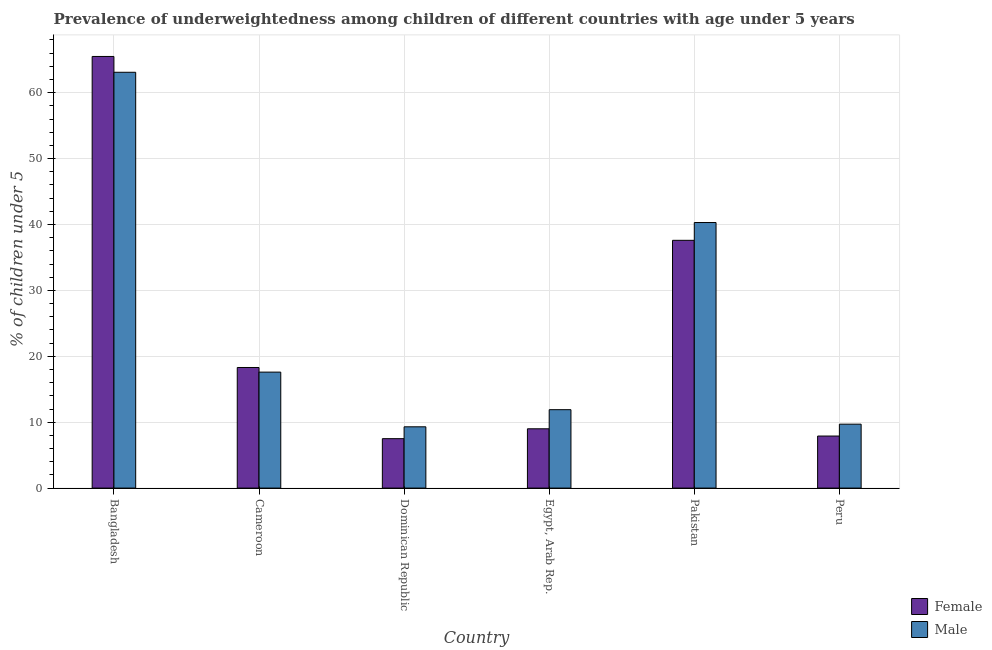How many different coloured bars are there?
Keep it short and to the point. 2. Are the number of bars per tick equal to the number of legend labels?
Provide a succinct answer. Yes. Are the number of bars on each tick of the X-axis equal?
Your answer should be very brief. Yes. How many bars are there on the 5th tick from the left?
Your answer should be very brief. 2. How many bars are there on the 1st tick from the right?
Your answer should be very brief. 2. What is the label of the 3rd group of bars from the left?
Your response must be concise. Dominican Republic. What is the percentage of underweighted male children in Egypt, Arab Rep.?
Ensure brevity in your answer.  11.9. Across all countries, what is the maximum percentage of underweighted female children?
Your answer should be compact. 65.5. Across all countries, what is the minimum percentage of underweighted male children?
Your answer should be very brief. 9.3. In which country was the percentage of underweighted female children maximum?
Give a very brief answer. Bangladesh. In which country was the percentage of underweighted female children minimum?
Provide a short and direct response. Dominican Republic. What is the total percentage of underweighted male children in the graph?
Your answer should be compact. 151.9. What is the difference between the percentage of underweighted female children in Bangladesh and that in Pakistan?
Your answer should be compact. 27.9. What is the difference between the percentage of underweighted female children in Bangladesh and the percentage of underweighted male children in Egypt, Arab Rep.?
Provide a short and direct response. 53.6. What is the average percentage of underweighted male children per country?
Provide a short and direct response. 25.32. What is the difference between the percentage of underweighted female children and percentage of underweighted male children in Bangladesh?
Make the answer very short. 2.4. In how many countries, is the percentage of underweighted female children greater than 66 %?
Offer a very short reply. 0. What is the ratio of the percentage of underweighted male children in Cameroon to that in Egypt, Arab Rep.?
Ensure brevity in your answer.  1.48. Is the percentage of underweighted female children in Cameroon less than that in Dominican Republic?
Ensure brevity in your answer.  No. Is the difference between the percentage of underweighted female children in Bangladesh and Pakistan greater than the difference between the percentage of underweighted male children in Bangladesh and Pakistan?
Offer a terse response. Yes. What is the difference between the highest and the second highest percentage of underweighted male children?
Provide a succinct answer. 22.8. What is the difference between the highest and the lowest percentage of underweighted male children?
Give a very brief answer. 53.8. Is the sum of the percentage of underweighted female children in Pakistan and Peru greater than the maximum percentage of underweighted male children across all countries?
Keep it short and to the point. No. What does the 1st bar from the left in Dominican Republic represents?
Provide a short and direct response. Female. How many countries are there in the graph?
Ensure brevity in your answer.  6. Are the values on the major ticks of Y-axis written in scientific E-notation?
Ensure brevity in your answer.  No. Does the graph contain grids?
Give a very brief answer. Yes. How are the legend labels stacked?
Your response must be concise. Vertical. What is the title of the graph?
Provide a short and direct response. Prevalence of underweightedness among children of different countries with age under 5 years. Does "Study and work" appear as one of the legend labels in the graph?
Offer a very short reply. No. What is the label or title of the Y-axis?
Provide a short and direct response.  % of children under 5. What is the  % of children under 5 of Female in Bangladesh?
Offer a terse response. 65.5. What is the  % of children under 5 of Male in Bangladesh?
Your answer should be compact. 63.1. What is the  % of children under 5 of Female in Cameroon?
Your answer should be very brief. 18.3. What is the  % of children under 5 in Male in Cameroon?
Provide a succinct answer. 17.6. What is the  % of children under 5 in Male in Dominican Republic?
Offer a very short reply. 9.3. What is the  % of children under 5 of Male in Egypt, Arab Rep.?
Keep it short and to the point. 11.9. What is the  % of children under 5 of Female in Pakistan?
Make the answer very short. 37.6. What is the  % of children under 5 in Male in Pakistan?
Your answer should be very brief. 40.3. What is the  % of children under 5 of Female in Peru?
Make the answer very short. 7.9. What is the  % of children under 5 of Male in Peru?
Provide a short and direct response. 9.7. Across all countries, what is the maximum  % of children under 5 of Female?
Your answer should be very brief. 65.5. Across all countries, what is the maximum  % of children under 5 of Male?
Provide a succinct answer. 63.1. Across all countries, what is the minimum  % of children under 5 of Female?
Provide a succinct answer. 7.5. Across all countries, what is the minimum  % of children under 5 of Male?
Your response must be concise. 9.3. What is the total  % of children under 5 in Female in the graph?
Provide a short and direct response. 145.8. What is the total  % of children under 5 in Male in the graph?
Give a very brief answer. 151.9. What is the difference between the  % of children under 5 in Female in Bangladesh and that in Cameroon?
Provide a short and direct response. 47.2. What is the difference between the  % of children under 5 in Male in Bangladesh and that in Cameroon?
Your answer should be compact. 45.5. What is the difference between the  % of children under 5 of Female in Bangladesh and that in Dominican Republic?
Give a very brief answer. 58. What is the difference between the  % of children under 5 of Male in Bangladesh and that in Dominican Republic?
Give a very brief answer. 53.8. What is the difference between the  % of children under 5 in Female in Bangladesh and that in Egypt, Arab Rep.?
Your answer should be very brief. 56.5. What is the difference between the  % of children under 5 of Male in Bangladesh and that in Egypt, Arab Rep.?
Provide a succinct answer. 51.2. What is the difference between the  % of children under 5 in Female in Bangladesh and that in Pakistan?
Offer a terse response. 27.9. What is the difference between the  % of children under 5 of Male in Bangladesh and that in Pakistan?
Your answer should be very brief. 22.8. What is the difference between the  % of children under 5 in Female in Bangladesh and that in Peru?
Your response must be concise. 57.6. What is the difference between the  % of children under 5 of Male in Bangladesh and that in Peru?
Your answer should be very brief. 53.4. What is the difference between the  % of children under 5 of Male in Cameroon and that in Dominican Republic?
Offer a very short reply. 8.3. What is the difference between the  % of children under 5 of Female in Cameroon and that in Pakistan?
Your answer should be very brief. -19.3. What is the difference between the  % of children under 5 of Male in Cameroon and that in Pakistan?
Your answer should be very brief. -22.7. What is the difference between the  % of children under 5 of Male in Cameroon and that in Peru?
Make the answer very short. 7.9. What is the difference between the  % of children under 5 of Female in Dominican Republic and that in Egypt, Arab Rep.?
Ensure brevity in your answer.  -1.5. What is the difference between the  % of children under 5 of Male in Dominican Republic and that in Egypt, Arab Rep.?
Ensure brevity in your answer.  -2.6. What is the difference between the  % of children under 5 in Female in Dominican Republic and that in Pakistan?
Your answer should be compact. -30.1. What is the difference between the  % of children under 5 of Male in Dominican Republic and that in Pakistan?
Make the answer very short. -31. What is the difference between the  % of children under 5 of Female in Dominican Republic and that in Peru?
Ensure brevity in your answer.  -0.4. What is the difference between the  % of children under 5 of Male in Dominican Republic and that in Peru?
Keep it short and to the point. -0.4. What is the difference between the  % of children under 5 of Female in Egypt, Arab Rep. and that in Pakistan?
Provide a succinct answer. -28.6. What is the difference between the  % of children under 5 in Male in Egypt, Arab Rep. and that in Pakistan?
Provide a short and direct response. -28.4. What is the difference between the  % of children under 5 in Female in Pakistan and that in Peru?
Keep it short and to the point. 29.7. What is the difference between the  % of children under 5 of Male in Pakistan and that in Peru?
Your response must be concise. 30.6. What is the difference between the  % of children under 5 of Female in Bangladesh and the  % of children under 5 of Male in Cameroon?
Give a very brief answer. 47.9. What is the difference between the  % of children under 5 in Female in Bangladesh and the  % of children under 5 in Male in Dominican Republic?
Make the answer very short. 56.2. What is the difference between the  % of children under 5 in Female in Bangladesh and the  % of children under 5 in Male in Egypt, Arab Rep.?
Keep it short and to the point. 53.6. What is the difference between the  % of children under 5 of Female in Bangladesh and the  % of children under 5 of Male in Pakistan?
Your answer should be very brief. 25.2. What is the difference between the  % of children under 5 in Female in Bangladesh and the  % of children under 5 in Male in Peru?
Your response must be concise. 55.8. What is the difference between the  % of children under 5 of Female in Cameroon and the  % of children under 5 of Male in Dominican Republic?
Offer a terse response. 9. What is the difference between the  % of children under 5 in Female in Cameroon and the  % of children under 5 in Male in Egypt, Arab Rep.?
Your response must be concise. 6.4. What is the difference between the  % of children under 5 in Female in Dominican Republic and the  % of children under 5 in Male in Egypt, Arab Rep.?
Offer a terse response. -4.4. What is the difference between the  % of children under 5 of Female in Dominican Republic and the  % of children under 5 of Male in Pakistan?
Ensure brevity in your answer.  -32.8. What is the difference between the  % of children under 5 in Female in Egypt, Arab Rep. and the  % of children under 5 in Male in Pakistan?
Your answer should be very brief. -31.3. What is the difference between the  % of children under 5 in Female in Pakistan and the  % of children under 5 in Male in Peru?
Ensure brevity in your answer.  27.9. What is the average  % of children under 5 in Female per country?
Offer a terse response. 24.3. What is the average  % of children under 5 in Male per country?
Your answer should be very brief. 25.32. What is the difference between the  % of children under 5 of Female and  % of children under 5 of Male in Cameroon?
Give a very brief answer. 0.7. What is the difference between the  % of children under 5 of Female and  % of children under 5 of Male in Dominican Republic?
Your answer should be very brief. -1.8. What is the difference between the  % of children under 5 of Female and  % of children under 5 of Male in Egypt, Arab Rep.?
Offer a terse response. -2.9. What is the difference between the  % of children under 5 in Female and  % of children under 5 in Male in Pakistan?
Give a very brief answer. -2.7. What is the ratio of the  % of children under 5 of Female in Bangladesh to that in Cameroon?
Your answer should be very brief. 3.58. What is the ratio of the  % of children under 5 of Male in Bangladesh to that in Cameroon?
Your answer should be compact. 3.59. What is the ratio of the  % of children under 5 in Female in Bangladesh to that in Dominican Republic?
Provide a succinct answer. 8.73. What is the ratio of the  % of children under 5 of Male in Bangladesh to that in Dominican Republic?
Ensure brevity in your answer.  6.78. What is the ratio of the  % of children under 5 in Female in Bangladesh to that in Egypt, Arab Rep.?
Provide a succinct answer. 7.28. What is the ratio of the  % of children under 5 in Male in Bangladesh to that in Egypt, Arab Rep.?
Your response must be concise. 5.3. What is the ratio of the  % of children under 5 of Female in Bangladesh to that in Pakistan?
Offer a very short reply. 1.74. What is the ratio of the  % of children under 5 in Male in Bangladesh to that in Pakistan?
Your answer should be compact. 1.57. What is the ratio of the  % of children under 5 of Female in Bangladesh to that in Peru?
Keep it short and to the point. 8.29. What is the ratio of the  % of children under 5 of Male in Bangladesh to that in Peru?
Offer a terse response. 6.51. What is the ratio of the  % of children under 5 in Female in Cameroon to that in Dominican Republic?
Offer a very short reply. 2.44. What is the ratio of the  % of children under 5 in Male in Cameroon to that in Dominican Republic?
Your answer should be very brief. 1.89. What is the ratio of the  % of children under 5 in Female in Cameroon to that in Egypt, Arab Rep.?
Your answer should be compact. 2.03. What is the ratio of the  % of children under 5 of Male in Cameroon to that in Egypt, Arab Rep.?
Your answer should be compact. 1.48. What is the ratio of the  % of children under 5 of Female in Cameroon to that in Pakistan?
Your answer should be compact. 0.49. What is the ratio of the  % of children under 5 of Male in Cameroon to that in Pakistan?
Offer a terse response. 0.44. What is the ratio of the  % of children under 5 of Female in Cameroon to that in Peru?
Your answer should be very brief. 2.32. What is the ratio of the  % of children under 5 in Male in Cameroon to that in Peru?
Make the answer very short. 1.81. What is the ratio of the  % of children under 5 of Female in Dominican Republic to that in Egypt, Arab Rep.?
Offer a terse response. 0.83. What is the ratio of the  % of children under 5 of Male in Dominican Republic to that in Egypt, Arab Rep.?
Your answer should be very brief. 0.78. What is the ratio of the  % of children under 5 in Female in Dominican Republic to that in Pakistan?
Offer a terse response. 0.2. What is the ratio of the  % of children under 5 of Male in Dominican Republic to that in Pakistan?
Your answer should be compact. 0.23. What is the ratio of the  % of children under 5 of Female in Dominican Republic to that in Peru?
Your answer should be very brief. 0.95. What is the ratio of the  % of children under 5 of Male in Dominican Republic to that in Peru?
Make the answer very short. 0.96. What is the ratio of the  % of children under 5 in Female in Egypt, Arab Rep. to that in Pakistan?
Keep it short and to the point. 0.24. What is the ratio of the  % of children under 5 in Male in Egypt, Arab Rep. to that in Pakistan?
Give a very brief answer. 0.3. What is the ratio of the  % of children under 5 in Female in Egypt, Arab Rep. to that in Peru?
Your response must be concise. 1.14. What is the ratio of the  % of children under 5 in Male in Egypt, Arab Rep. to that in Peru?
Your answer should be compact. 1.23. What is the ratio of the  % of children under 5 of Female in Pakistan to that in Peru?
Offer a terse response. 4.76. What is the ratio of the  % of children under 5 in Male in Pakistan to that in Peru?
Your answer should be compact. 4.15. What is the difference between the highest and the second highest  % of children under 5 in Female?
Your answer should be very brief. 27.9. What is the difference between the highest and the second highest  % of children under 5 in Male?
Your answer should be compact. 22.8. What is the difference between the highest and the lowest  % of children under 5 in Male?
Offer a very short reply. 53.8. 